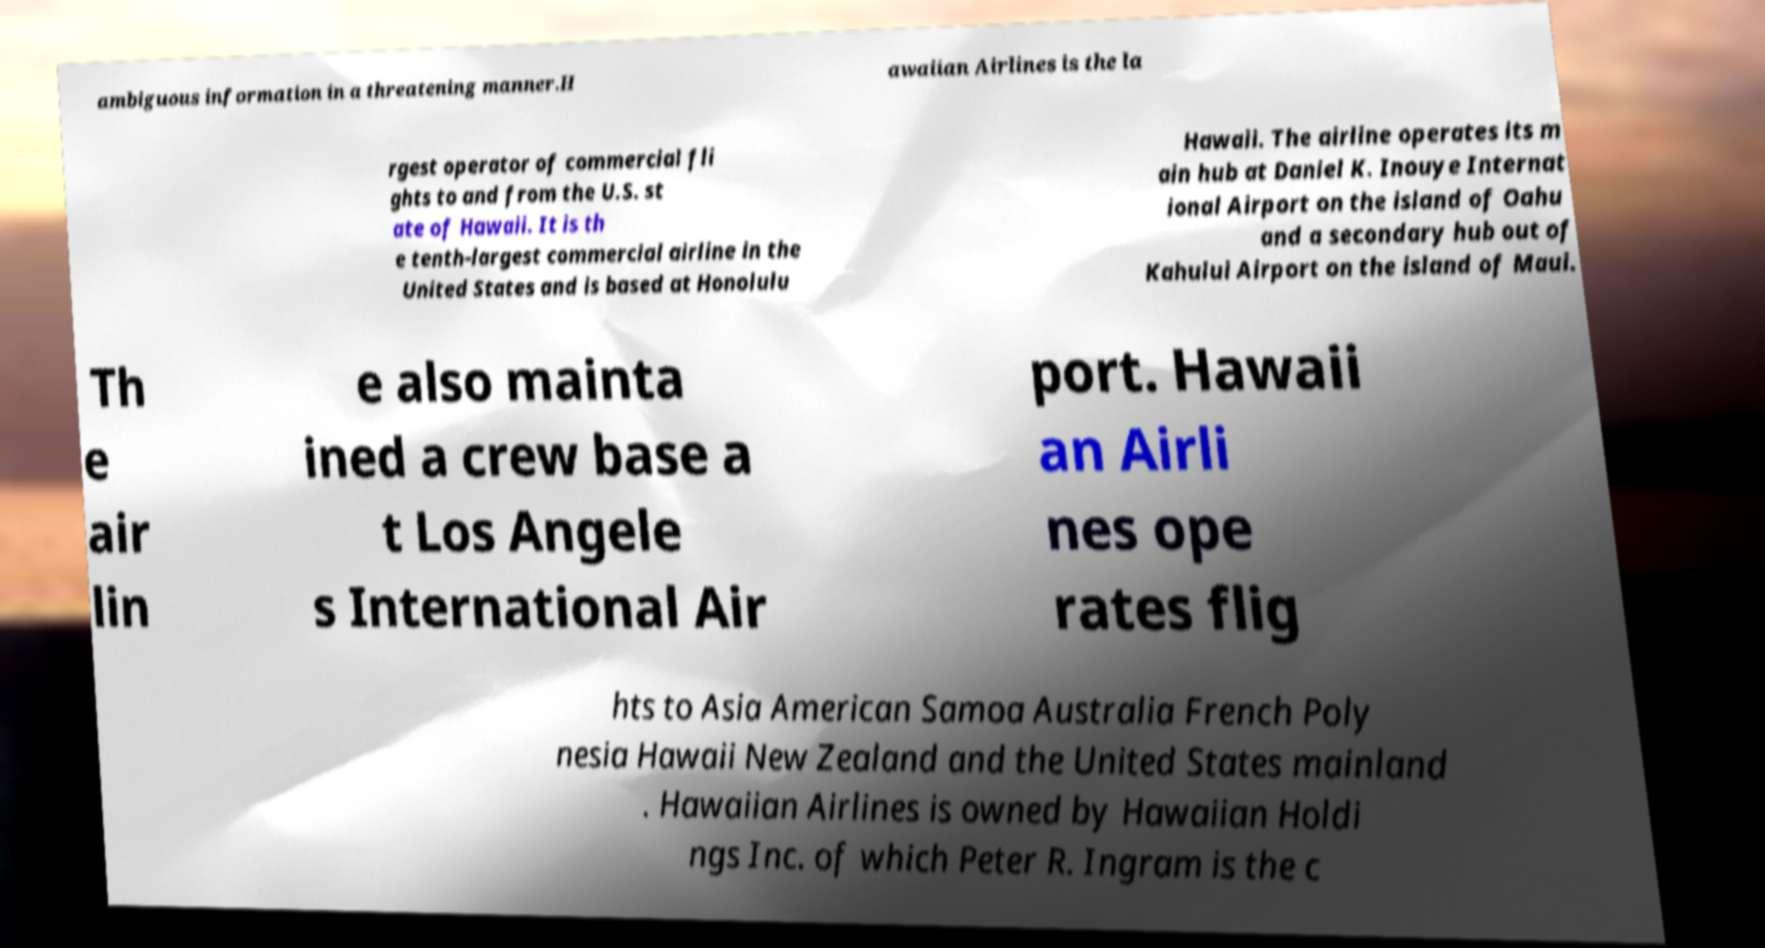Please read and relay the text visible in this image. What does it say? ambiguous information in a threatening manner.H awaiian Airlines is the la rgest operator of commercial fli ghts to and from the U.S. st ate of Hawaii. It is th e tenth-largest commercial airline in the United States and is based at Honolulu Hawaii. The airline operates its m ain hub at Daniel K. Inouye Internat ional Airport on the island of Oahu and a secondary hub out of Kahului Airport on the island of Maui. Th e air lin e also mainta ined a crew base a t Los Angele s International Air port. Hawaii an Airli nes ope rates flig hts to Asia American Samoa Australia French Poly nesia Hawaii New Zealand and the United States mainland . Hawaiian Airlines is owned by Hawaiian Holdi ngs Inc. of which Peter R. Ingram is the c 